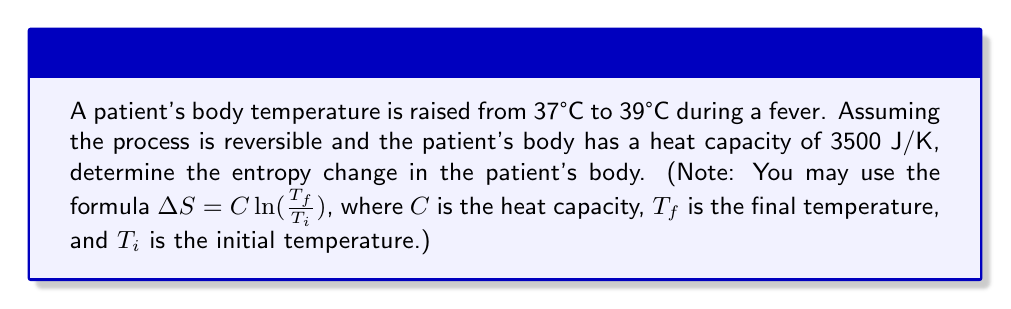Could you help me with this problem? Let's approach this step-by-step:

1) First, we need to convert the temperatures from Celsius to Kelvin:
   $T_i = 37°C + 273.15 = 310.15 K$
   $T_f = 39°C + 273.15 = 312.15 K$

2) We're given the heat capacity $C = 3500 J/K$

3) Now we can use the formula for entropy change in a reversible process:

   $$\Delta S = C \ln(\frac{T_f}{T_i})$$

4) Substituting our values:

   $$\Delta S = 3500 \ln(\frac{312.15}{310.15})$$

5) Let's calculate:

   $$\Delta S = 3500 \ln(1.00645)$$

6) $\ln(1.00645) \approx 0.00643$

7) Therefore:

   $$\Delta S = 3500 \times 0.00643 \approx 22.505 J/K$$
Answer: $22.5 J/K$ 